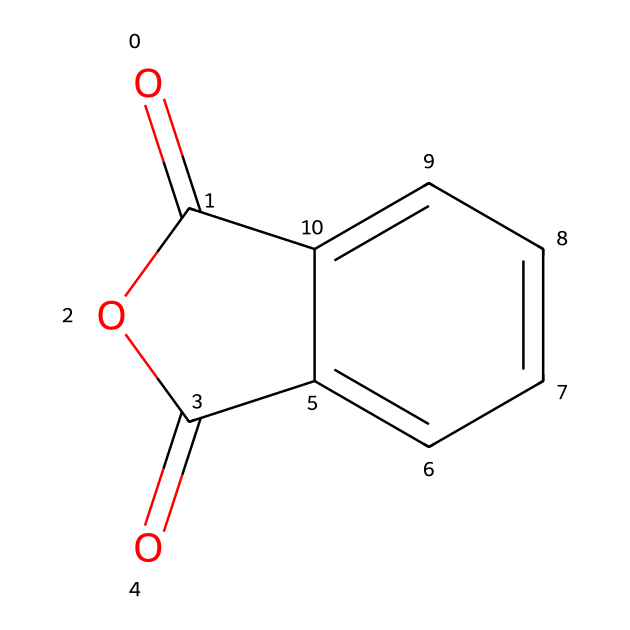What is the molecular formula of phthalic anhydride? To determine the molecular formula, we identify the atoms from the SMILES representation. There are 8 carbon atoms (c), 4 oxygen atoms (O), and 4 hydrogen atoms (h). This gives us the formula C8H4O3.
Answer: C8H4O3 How many rings are present in the structure? Analyzing the structure, we find that there are two interconnected carbonyl (C=O) groups and a five-membered anhydride ring present. This indicates one ring in the chemical structure.
Answer: 1 What functional groups are present in phthalic anhydride? Phthalic anhydride contains an anhydride functional group (which consists of the cyclic structure formed with two carbonyls) and a benzene ring due to the aromatic carbon atoms.
Answer: anhydride and benzene What is the significance of the carbonyl groups in this compound? The carbonyl groups (C=O) are crucial as they contribute to the reactivity of the anhydride, allowing it to participate in reactions such as nucleophilic acyl substitution. This reactivity is significant for its applications in ink pigments.
Answer: reactivity What is the total number of double bonds in phthalic anhydride? By examining the structure, there are 4 double bonds; two are in the carbonyls and two in the benzene ring.
Answer: 4 How does the structure of phthalic anhydride affect its use in ink pigments? The presence of the anhydride group and the aromatic ring enhances the compound's ability to provide strong color and stability, making it suitable for use in pigments. The aromatic nature contributes to the conjugated system; therefore, stability and color intensity are increased.
Answer: strong color and stability 